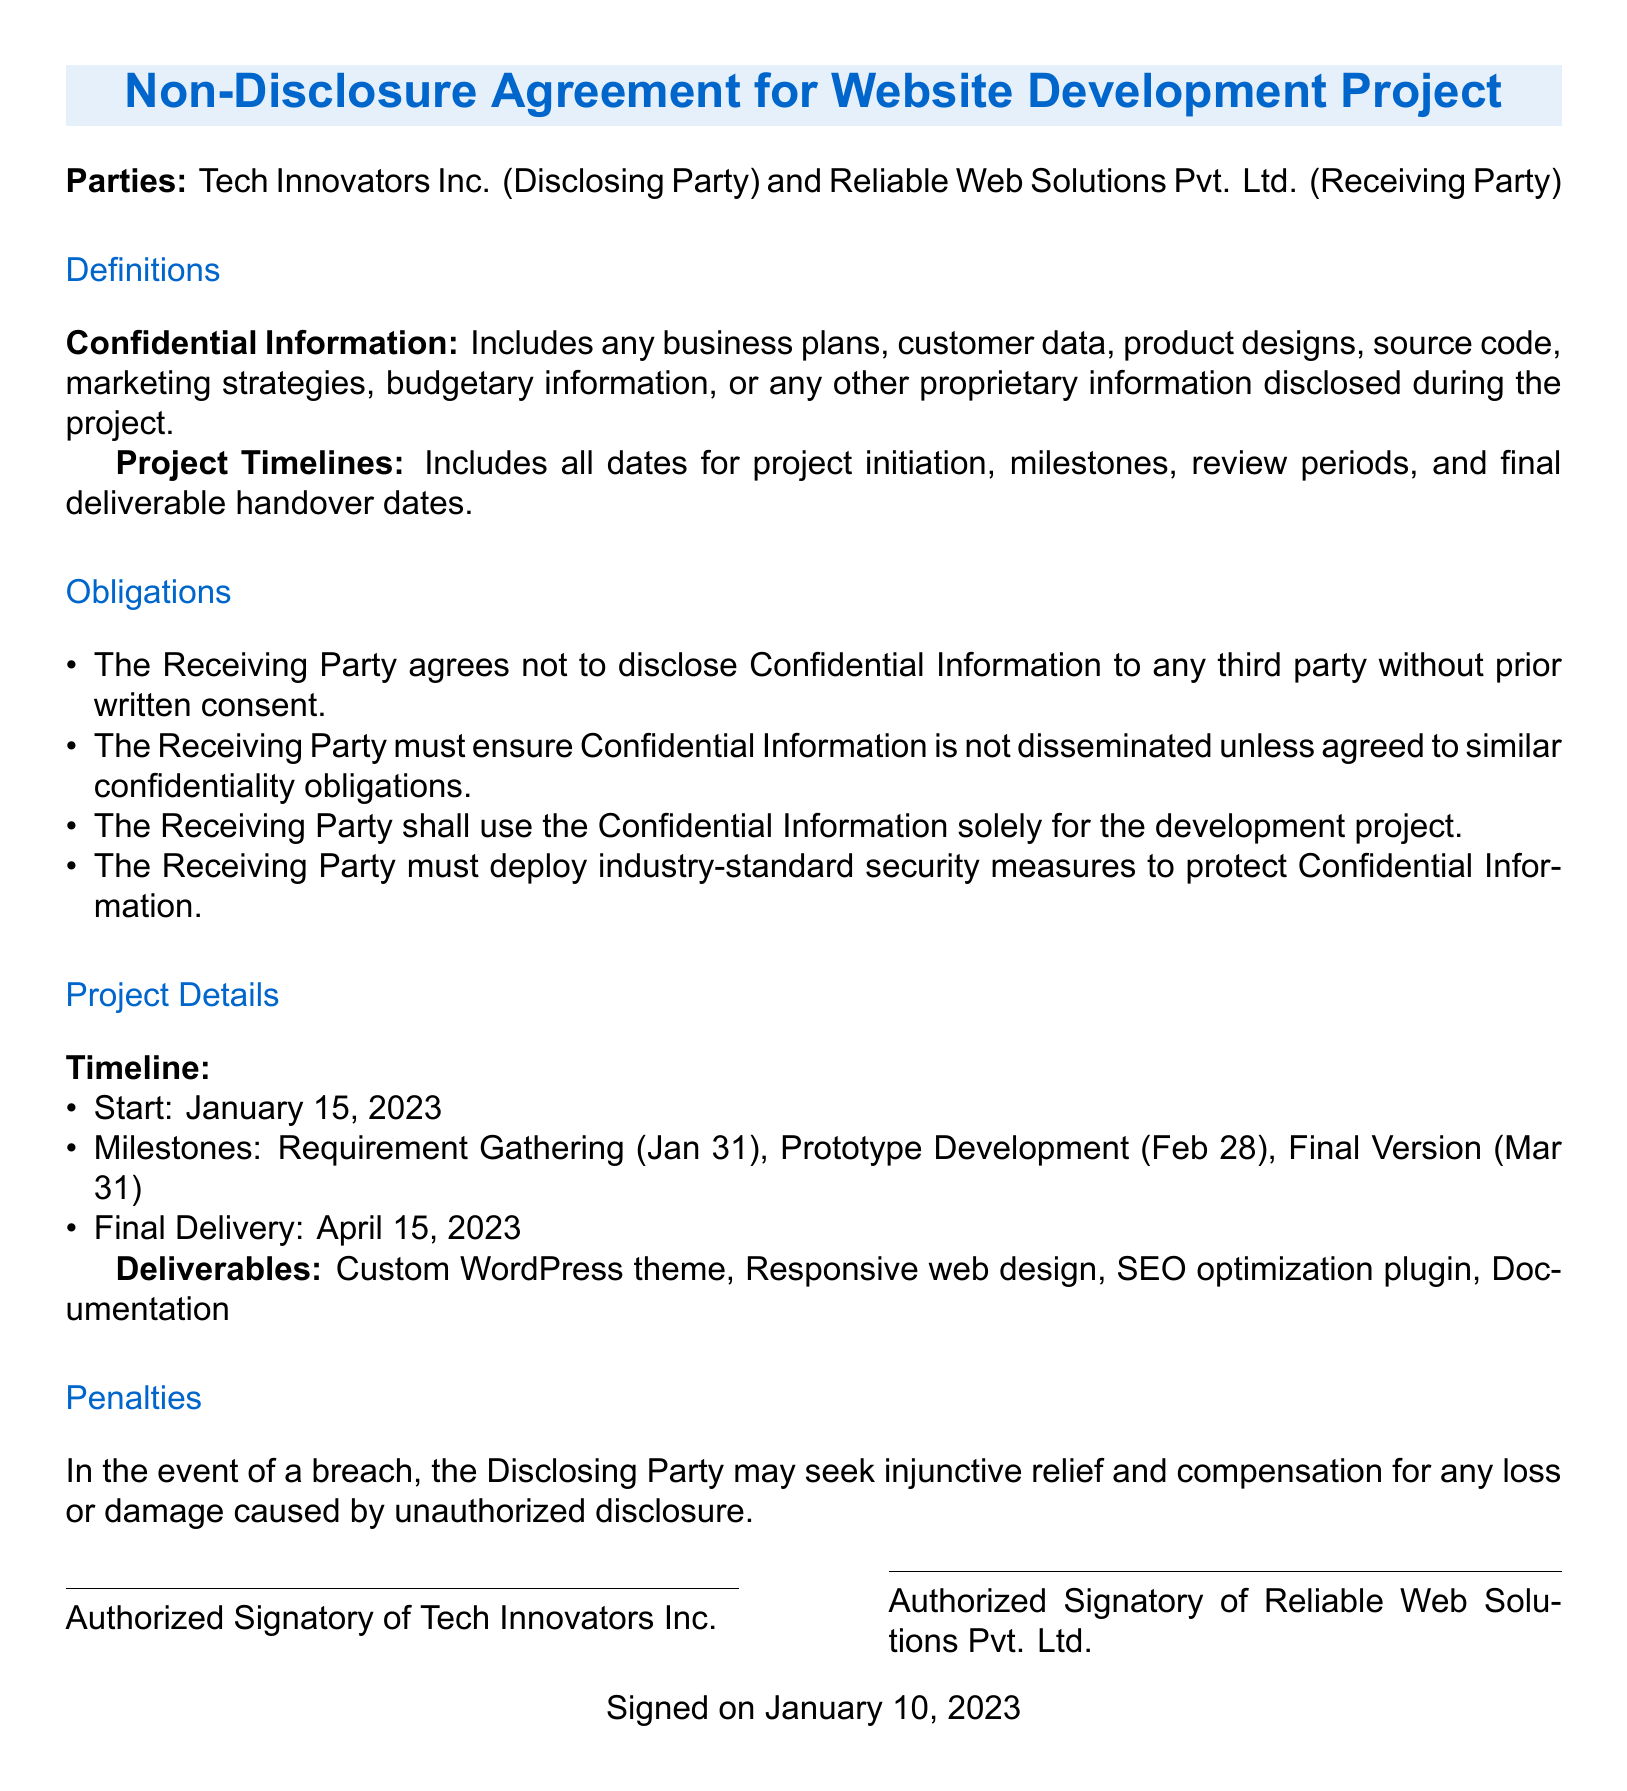What is the disclosing party's name? The disclosing party is identified as Tech Innovators Inc. in the document.
Answer: Tech Innovators Inc What is the main type of project described? The project pertains to the development of a website, as stated in the title of the document.
Answer: Website Development Project What are the deliverables listed in the document? The document specifies the deliverables, which include a custom WordPress theme, responsive web design, SEO optimization plugin, and documentation.
Answer: Custom WordPress theme, Responsive web design, SEO optimization plugin, Documentation When is the final delivery date? The final delivery date is explicitly stated as April 15, 2023, in the project details.
Answer: April 15, 2023 What security measures are required for Confidential Information? The document states that the Receiving Party must deploy industry-standard security measures.
Answer: Industry-standard security measures What is the consequence of a breach of the NDA? The document mentions specific penalties, including seeking injunctive relief and compensation for losses.
Answer: Injunctive relief and compensation What is the start date of the project? The project initiation date is mentioned as January 15, 2023, in the project timeline.
Answer: January 15, 2023 Who must sign the agreement? The document requires an authorized signatory from both parties to sign the agreement.
Answer: Authorized signatory What is considered Confidential Information? Confidential Information encompasses business plans, customer data, product designs, and other proprietary information.
Answer: Business plans, customer data, product designs, etc 